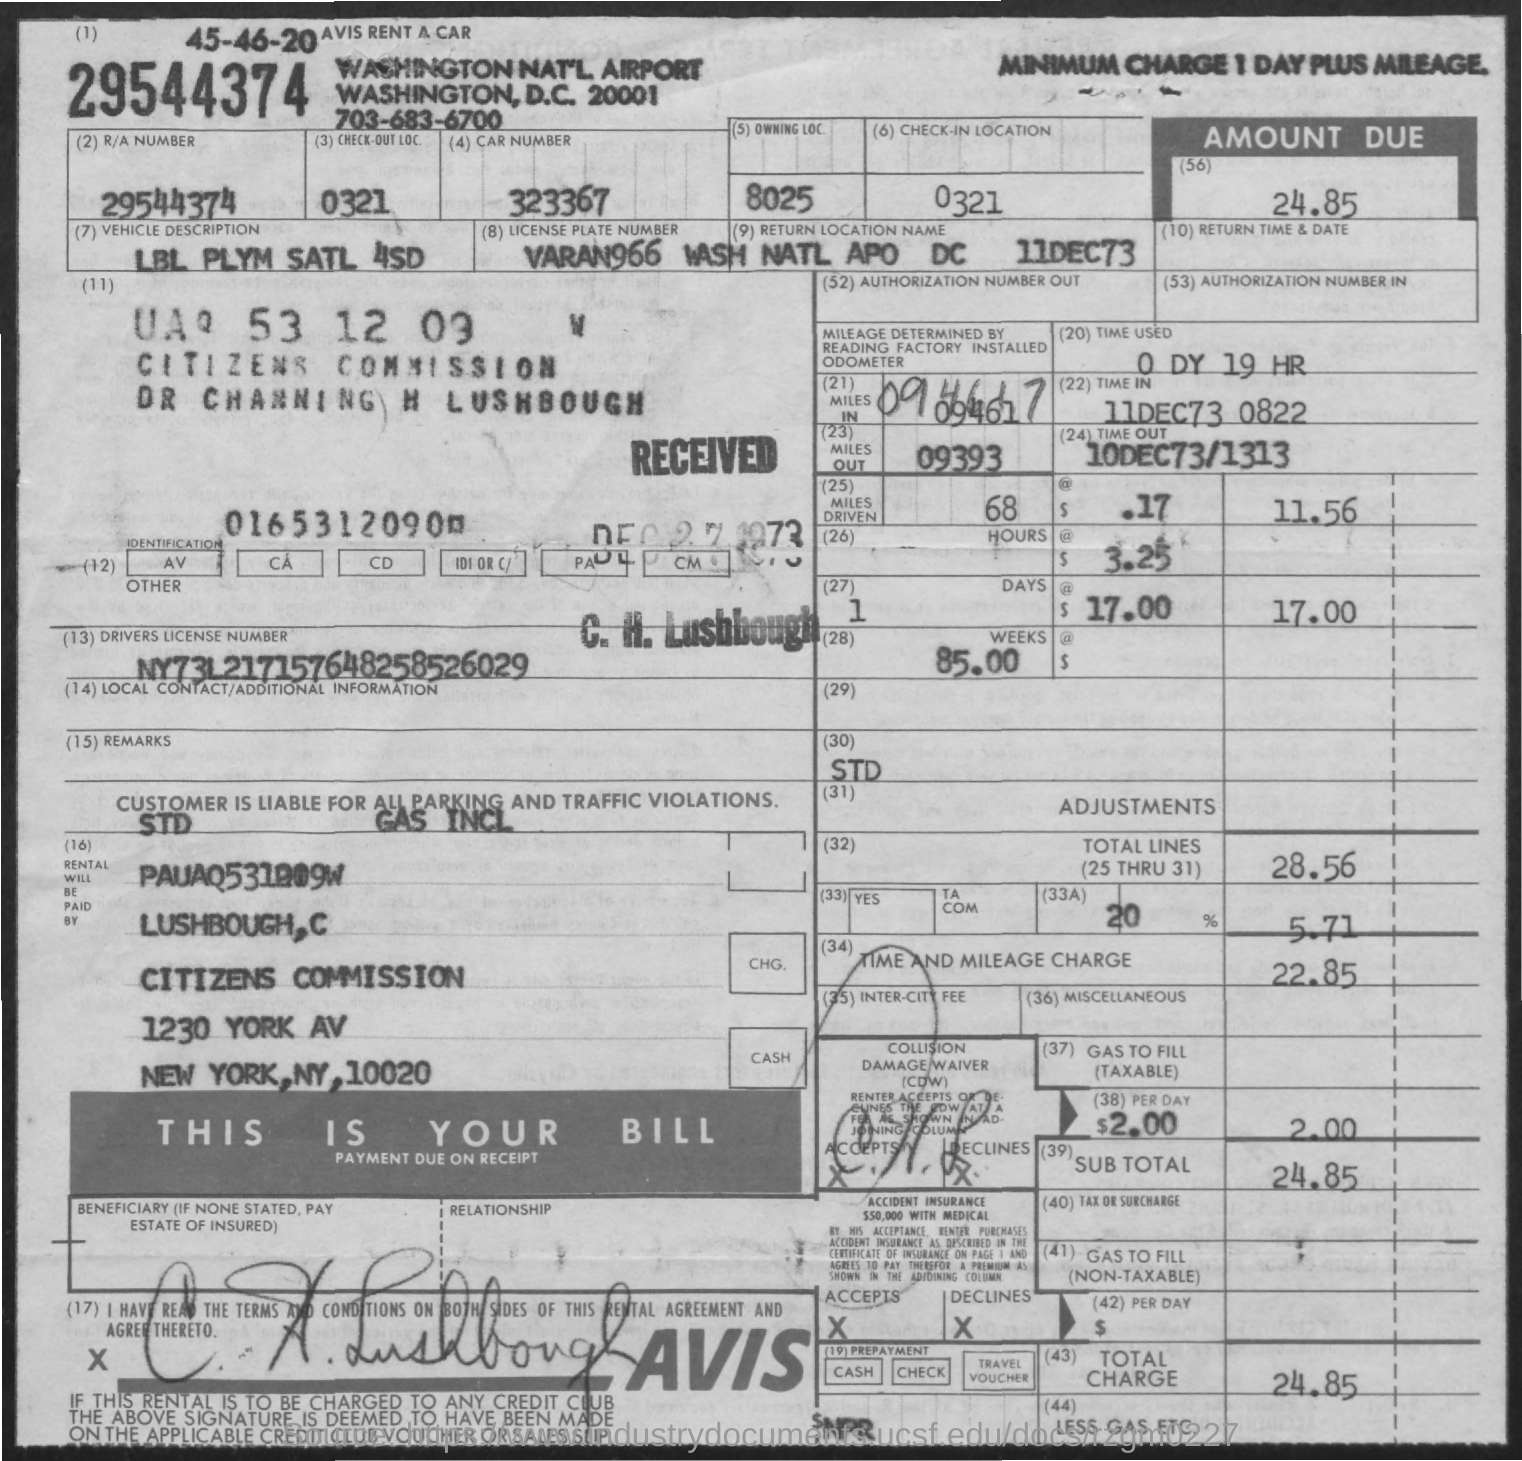What is the R/A Number of the car?
Make the answer very short. 29544374. What is the vehicle description mentioned in the document?
Provide a short and direct response. LBL PLYM SATL 4SD. What is the amount due as per the doument?
Ensure brevity in your answer.  24.85. What is the driver's license number given in the document?
Offer a very short reply. NY73L217157648258526029. What is the time used as given in the document?
Offer a terse response. 0 dy 19 hr. How much is the time and mileage charge?
Your response must be concise. 22.85. 